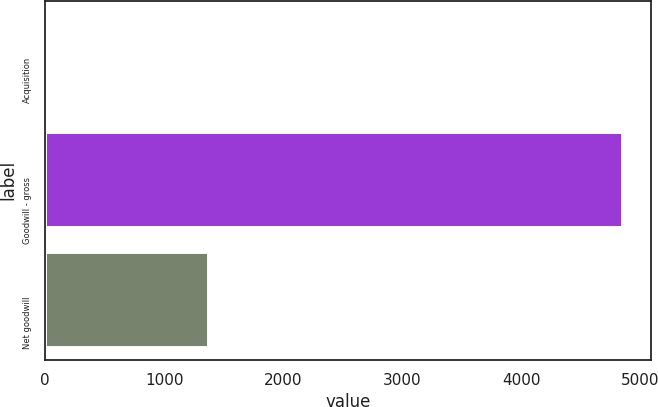<chart> <loc_0><loc_0><loc_500><loc_500><bar_chart><fcel>Acquisition<fcel>Goodwill - gross<fcel>Net goodwill<nl><fcel>26<fcel>4850<fcel>1373<nl></chart> 